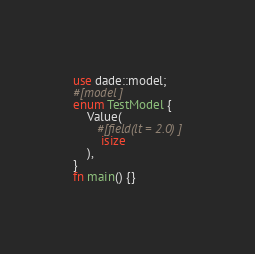<code> <loc_0><loc_0><loc_500><loc_500><_Rust_>use dade::model;
#[model]
enum TestModel {
    Value(
       #[field(lt = 2.0)]
        isize
    ),
}
fn main() {}
</code> 